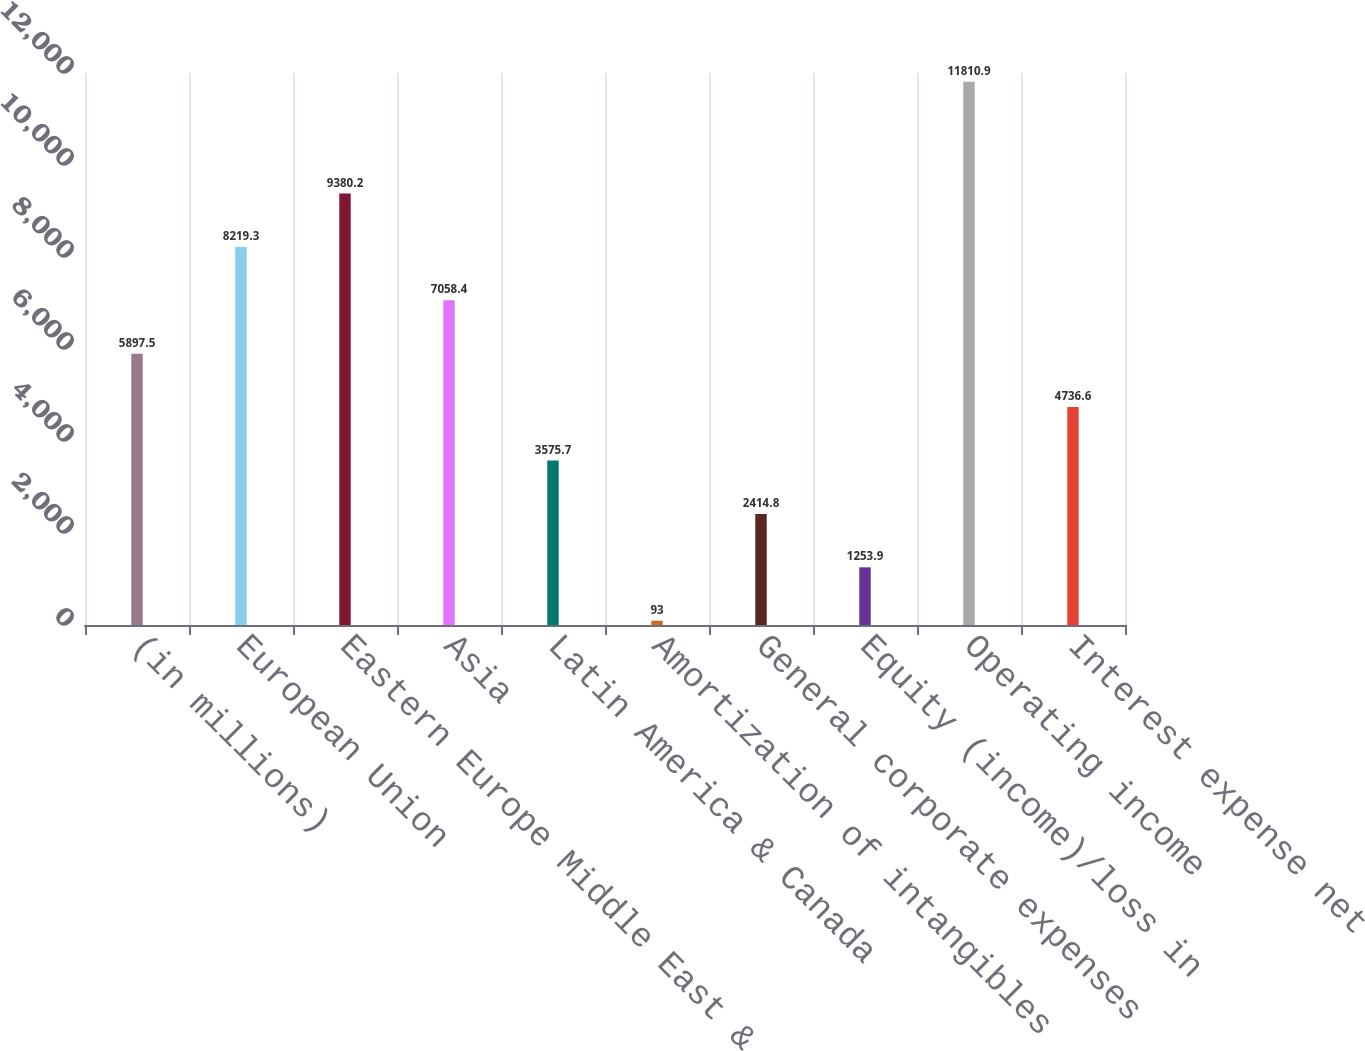Convert chart. <chart><loc_0><loc_0><loc_500><loc_500><bar_chart><fcel>(in millions)<fcel>European Union<fcel>Eastern Europe Middle East &<fcel>Asia<fcel>Latin America & Canada<fcel>Amortization of intangibles<fcel>General corporate expenses<fcel>Equity (income)/loss in<fcel>Operating income<fcel>Interest expense net<nl><fcel>5897.5<fcel>8219.3<fcel>9380.2<fcel>7058.4<fcel>3575.7<fcel>93<fcel>2414.8<fcel>1253.9<fcel>11810.9<fcel>4736.6<nl></chart> 